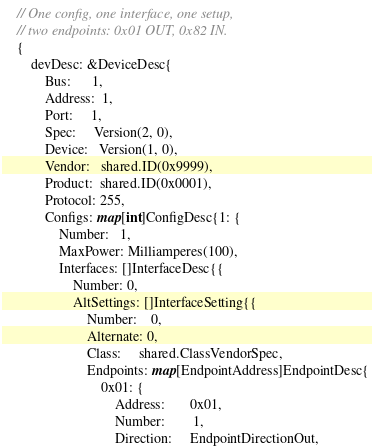<code> <loc_0><loc_0><loc_500><loc_500><_Go_>	// One config, one interface, one setup,
	// two endpoints: 0x01 OUT, 0x82 IN.
	{
		devDesc: &DeviceDesc{
			Bus:      1,
			Address:  1,
			Port:     1,
			Spec:     Version(2, 0),
			Device:   Version(1, 0),
			Vendor:   shared.ID(0x9999),
			Product:  shared.ID(0x0001),
			Protocol: 255,
			Configs: map[int]ConfigDesc{1: {
				Number:   1,
				MaxPower: Milliamperes(100),
				Interfaces: []InterfaceDesc{{
					Number: 0,
					AltSettings: []InterfaceSetting{{
						Number:    0,
						Alternate: 0,
						Class:     shared.ClassVendorSpec,
						Endpoints: map[EndpointAddress]EndpointDesc{
							0x01: {
								Address:       0x01,
								Number:        1,
								Direction:     EndpointDirectionOut,</code> 